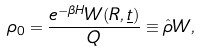<formula> <loc_0><loc_0><loc_500><loc_500>\rho _ { 0 } = \frac { e ^ { - \beta H } W ( R , \underline { t } ) } { Q } \equiv \hat { \rho } W ,</formula> 